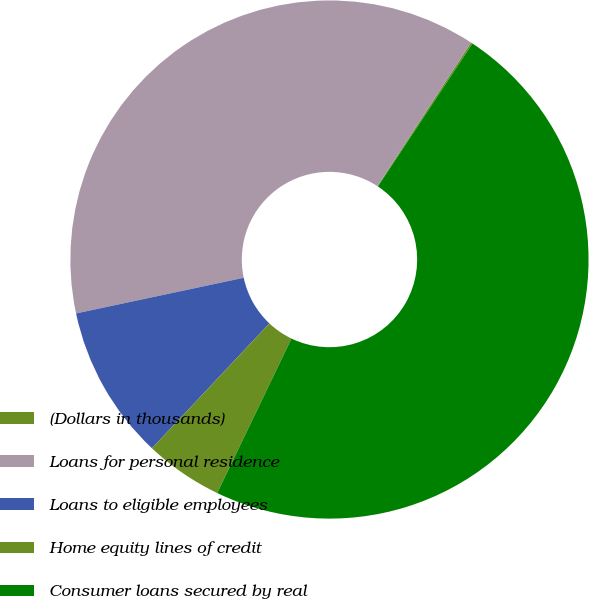<chart> <loc_0><loc_0><loc_500><loc_500><pie_chart><fcel>(Dollars in thousands)<fcel>Loans for personal residence<fcel>Loans to eligible employees<fcel>Home equity lines of credit<fcel>Consumer loans secured by real<nl><fcel>0.11%<fcel>37.53%<fcel>9.65%<fcel>4.88%<fcel>47.82%<nl></chart> 